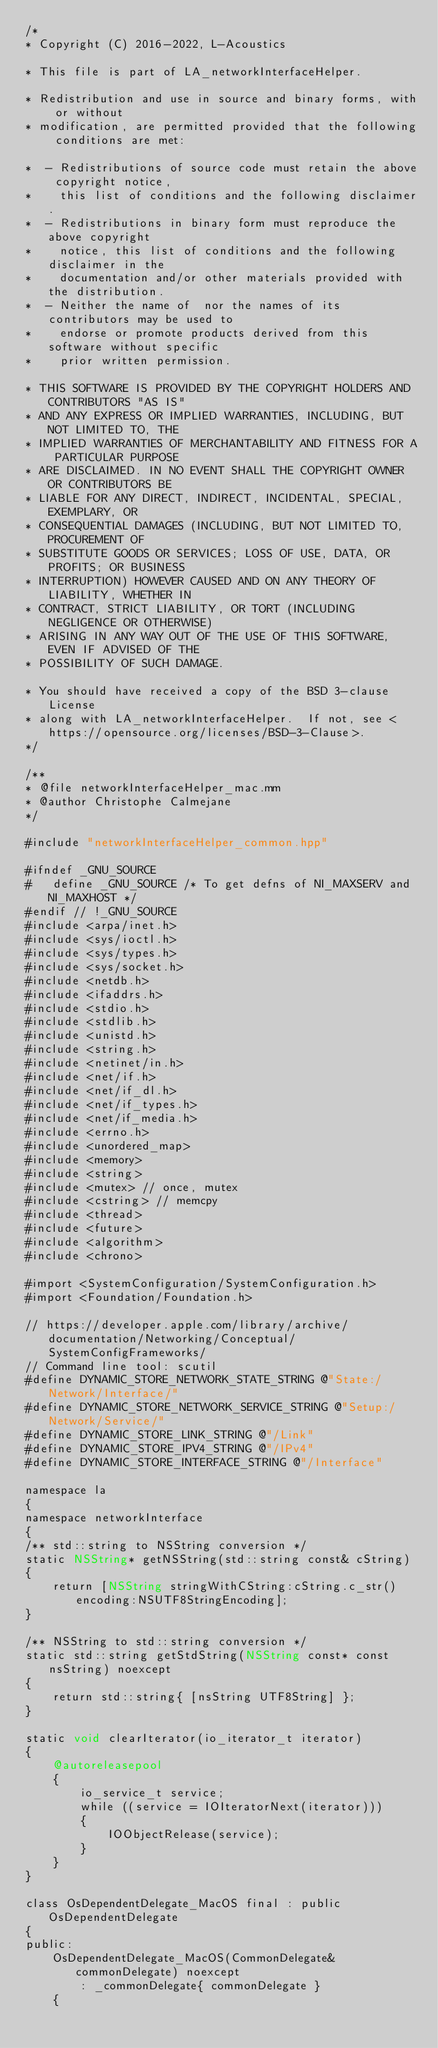<code> <loc_0><loc_0><loc_500><loc_500><_ObjectiveC_>/*
* Copyright (C) 2016-2022, L-Acoustics

* This file is part of LA_networkInterfaceHelper.

* Redistribution and use in source and binary forms, with or without
* modification, are permitted provided that the following conditions are met:

*  - Redistributions of source code must retain the above copyright notice,
*    this list of conditions and the following disclaimer.
*  - Redistributions in binary form must reproduce the above copyright
*    notice, this list of conditions and the following disclaimer in the
*    documentation and/or other materials provided with the distribution.
*  - Neither the name of  nor the names of its contributors may be used to
*    endorse or promote products derived from this software without specific
*    prior written permission.

* THIS SOFTWARE IS PROVIDED BY THE COPYRIGHT HOLDERS AND CONTRIBUTORS "AS IS"
* AND ANY EXPRESS OR IMPLIED WARRANTIES, INCLUDING, BUT NOT LIMITED TO, THE
* IMPLIED WARRANTIES OF MERCHANTABILITY AND FITNESS FOR A PARTICULAR PURPOSE
* ARE DISCLAIMED. IN NO EVENT SHALL THE COPYRIGHT OWNER OR CONTRIBUTORS BE
* LIABLE FOR ANY DIRECT, INDIRECT, INCIDENTAL, SPECIAL, EXEMPLARY, OR
* CONSEQUENTIAL DAMAGES (INCLUDING, BUT NOT LIMITED TO, PROCUREMENT OF
* SUBSTITUTE GOODS OR SERVICES; LOSS OF USE, DATA, OR PROFITS; OR BUSINESS
* INTERRUPTION) HOWEVER CAUSED AND ON ANY THEORY OF LIABILITY, WHETHER IN
* CONTRACT, STRICT LIABILITY, OR TORT (INCLUDING NEGLIGENCE OR OTHERWISE)
* ARISING IN ANY WAY OUT OF THE USE OF THIS SOFTWARE, EVEN IF ADVISED OF THE
* POSSIBILITY OF SUCH DAMAGE.

* You should have received a copy of the BSD 3-clause License
* along with LA_networkInterfaceHelper.  If not, see <https://opensource.org/licenses/BSD-3-Clause>.
*/

/**
* @file networkInterfaceHelper_mac.mm
* @author Christophe Calmejane
*/

#include "networkInterfaceHelper_common.hpp"

#ifndef _GNU_SOURCE
#	define _GNU_SOURCE /* To get defns of NI_MAXSERV and NI_MAXHOST */
#endif // !_GNU_SOURCE
#include <arpa/inet.h>
#include <sys/ioctl.h>
#include <sys/types.h>
#include <sys/socket.h>
#include <netdb.h>
#include <ifaddrs.h>
#include <stdio.h>
#include <stdlib.h>
#include <unistd.h>
#include <string.h>
#include <netinet/in.h>
#include <net/if.h>
#include <net/if_dl.h>
#include <net/if_types.h>
#include <net/if_media.h>
#include <errno.h>
#include <unordered_map>
#include <memory>
#include <string>
#include <mutex> // once, mutex
#include <cstring> // memcpy
#include <thread>
#include <future>
#include <algorithm>
#include <chrono>

#import <SystemConfiguration/SystemConfiguration.h>
#import <Foundation/Foundation.h>

// https://developer.apple.com/library/archive/documentation/Networking/Conceptual/SystemConfigFrameworks/
// Command line tool: scutil
#define DYNAMIC_STORE_NETWORK_STATE_STRING @"State:/Network/Interface/"
#define DYNAMIC_STORE_NETWORK_SERVICE_STRING @"Setup:/Network/Service/"
#define DYNAMIC_STORE_LINK_STRING @"/Link"
#define DYNAMIC_STORE_IPV4_STRING @"/IPv4"
#define DYNAMIC_STORE_INTERFACE_STRING @"/Interface"

namespace la
{
namespace networkInterface
{
/** std::string to NSString conversion */
static NSString* getNSString(std::string const& cString)
{
	return [NSString stringWithCString:cString.c_str() encoding:NSUTF8StringEncoding];
}

/** NSString to std::string conversion */
static std::string getStdString(NSString const* const nsString) noexcept
{
	return std::string{ [nsString UTF8String] };
}

static void clearIterator(io_iterator_t iterator)
{
	@autoreleasepool
	{
		io_service_t service;
		while ((service = IOIteratorNext(iterator)))
		{
			IOObjectRelease(service);
		}
	}
}

class OsDependentDelegate_MacOS final : public OsDependentDelegate
{
public:
	OsDependentDelegate_MacOS(CommonDelegate& commonDelegate) noexcept
		: _commonDelegate{ commonDelegate }
	{</code> 